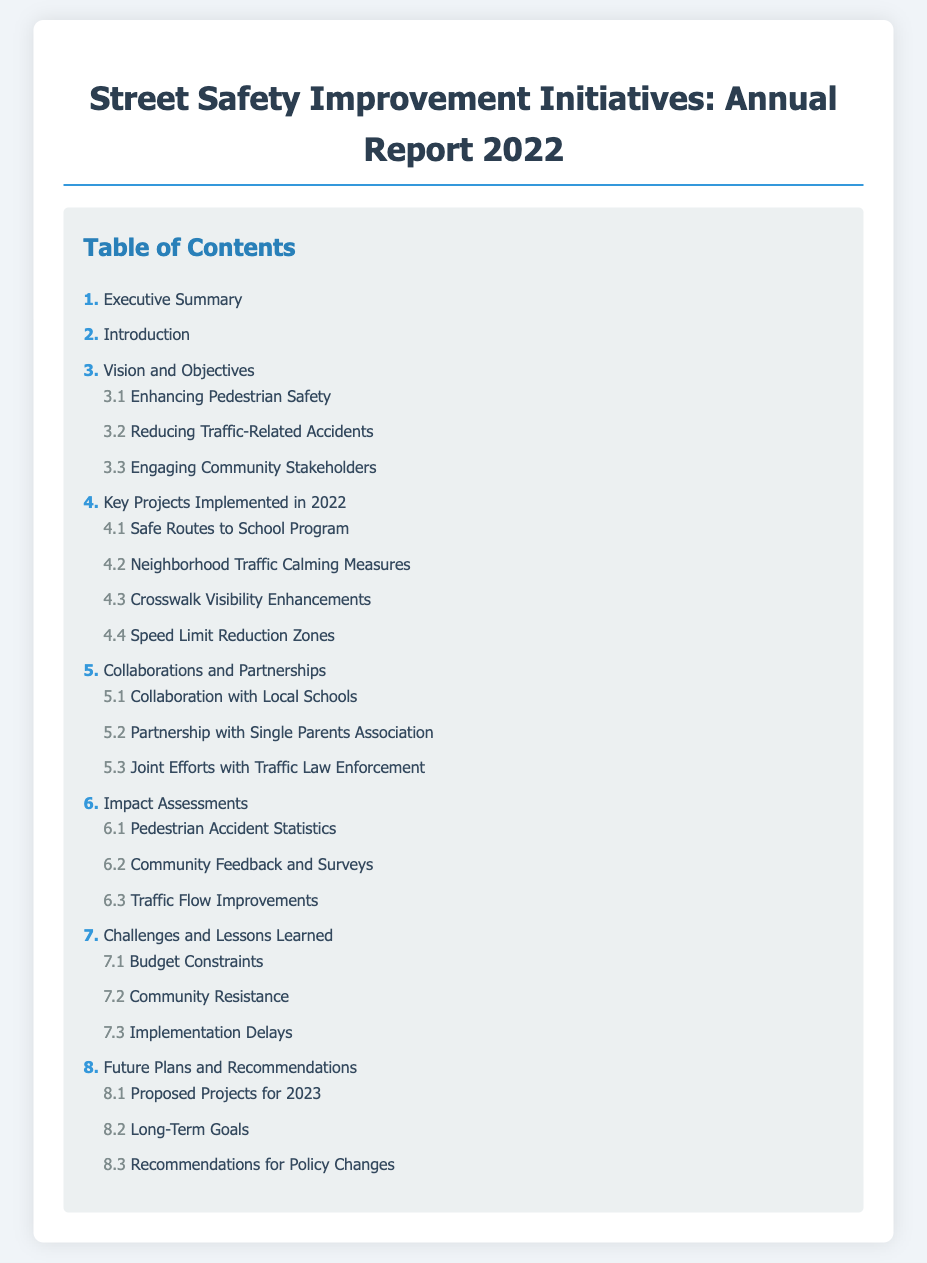What is the title of the report? The title of the report is stated in the document's heading.
Answer: Street Safety Improvement Initiatives: Annual Report 2022 What section discusses enhancing pedestrian safety? The title of the section is listed in the Table of Contents under Vision and Objectives.
Answer: Enhancing Pedestrian Safety How many key projects were implemented in 2022? The number of projects is indicated by the number of subsections under Key Projects Implemented in 2022.
Answer: 4 What is the first subsection under Collaborations and Partnerships? The first subsection is identified in the Table of Contents under Collaborations and Partnerships.
Answer: Collaboration with Local Schools Which section addresses community feedback? This section is referenced in the Table of Contents, focusing on the impact of initiatives.
Answer: Community Feedback and Surveys What are the long-term goals discussed in the report? The long-term goals are stated under Future Plans and Recommendations.
Answer: Long-Term Goals What is the focus of the subsection 7.2? This subsection describes challenges faced during the initiatives, as noted in the Table of Contents.
Answer: Community Resistance How many recommendations are provided for future policy changes? The number of recommendations can be found in the document's section on policy recommendations.
Answer: 1 